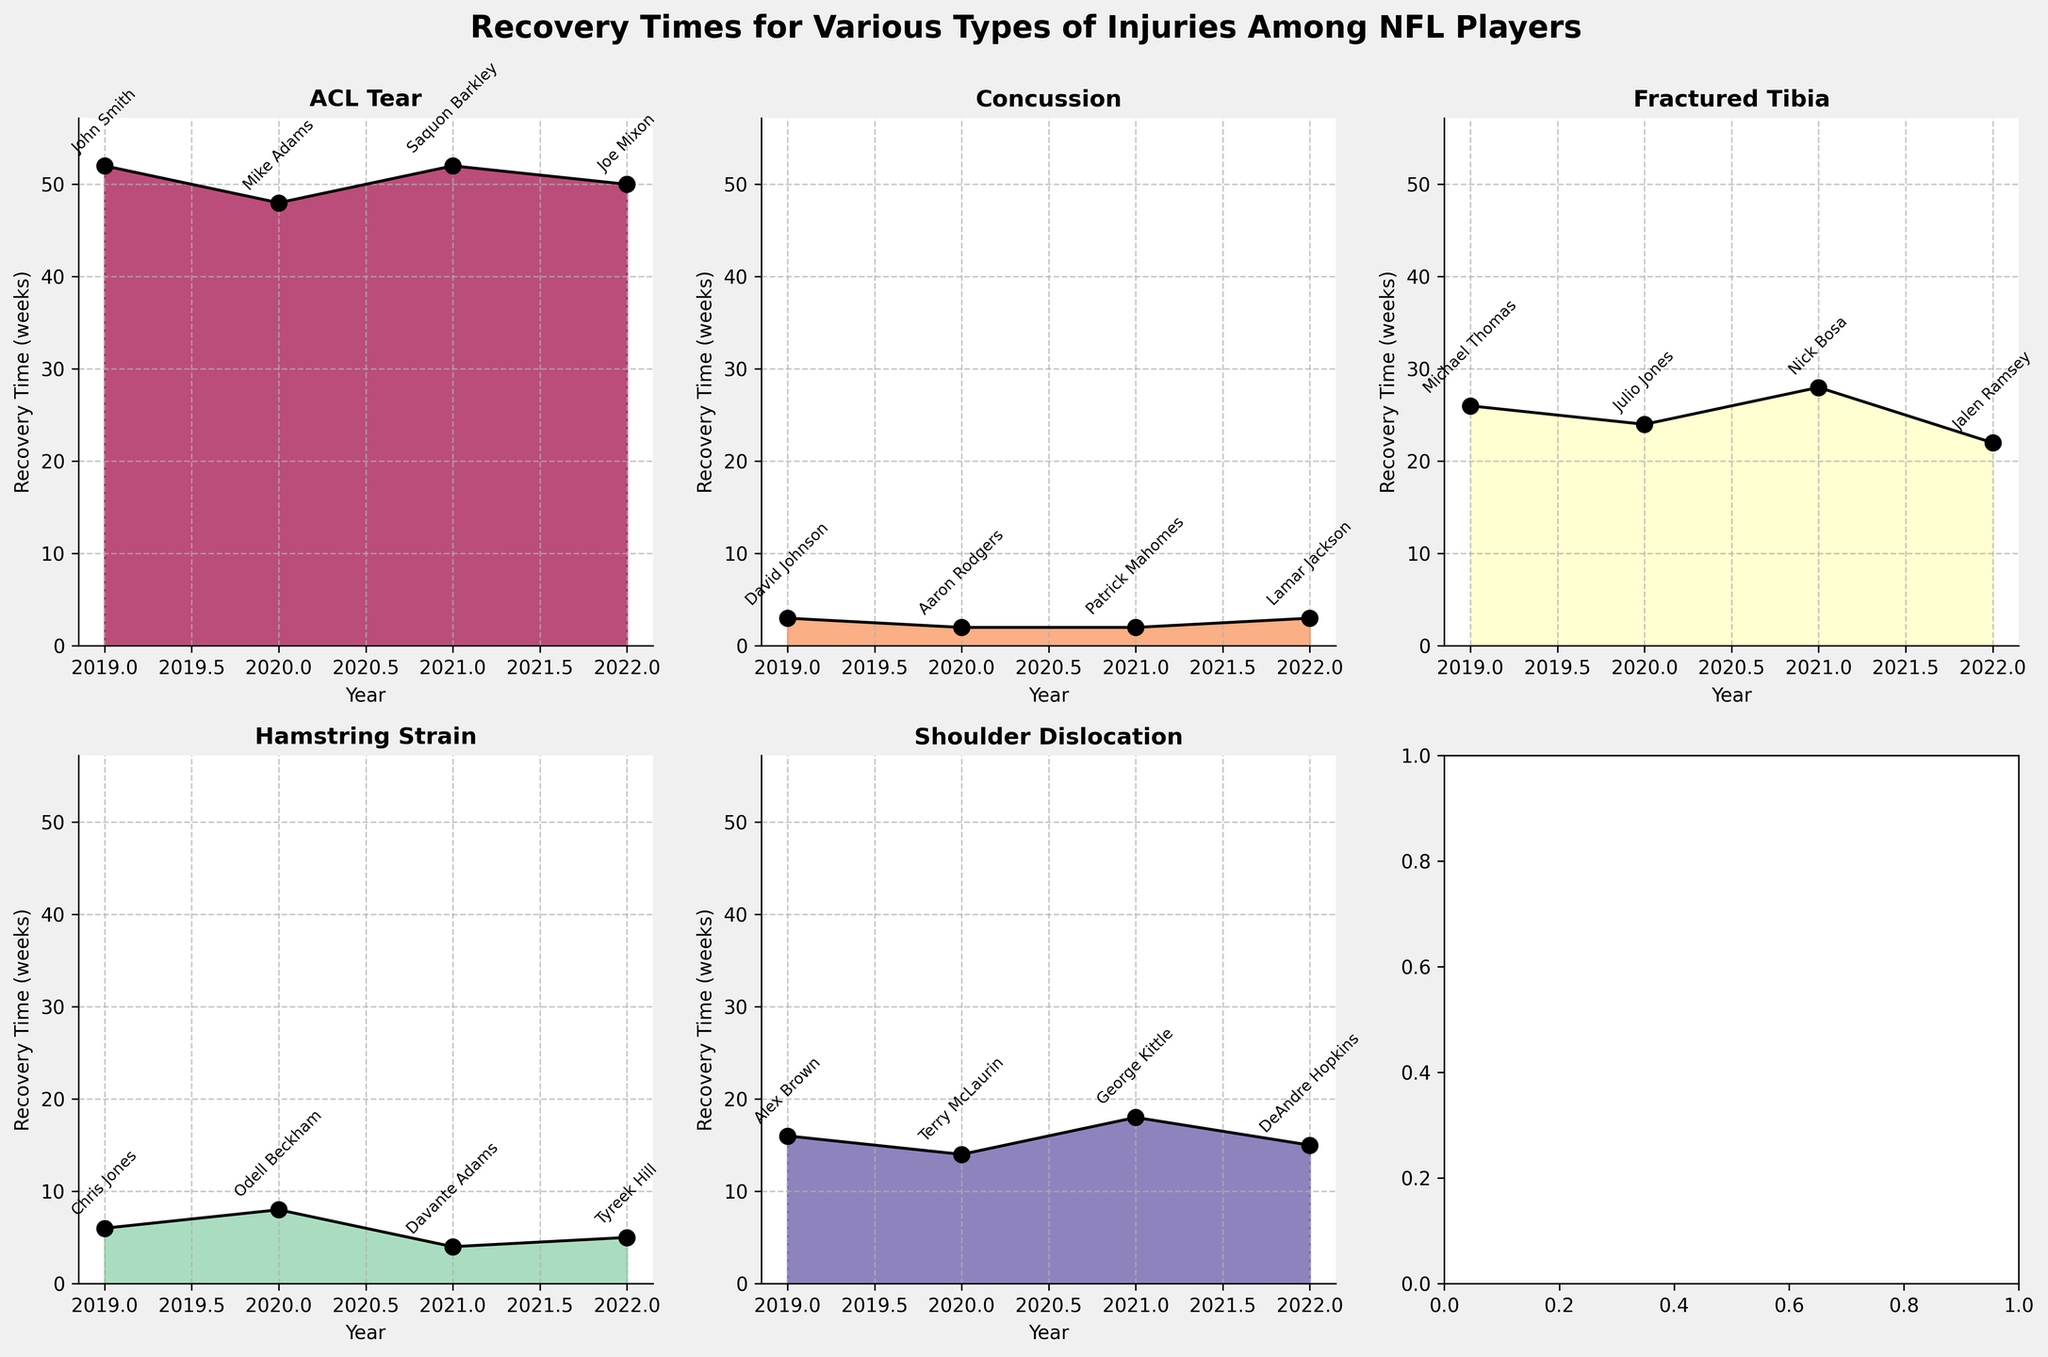What is the title of the figure? The title is displayed at the top of the figure in bold text. It states the overall subject of the data being represented.
Answer: Recovery Times for Various Types of Injuries Among NFL Players Which injury type shows the longest recovery time in 2021? The subplot titled "ACL Tear" shows the longest recovery time for 2021, with a value of 52 weeks attributed to Saquon Barkley.
Answer: ACL Tear How many players suffered from Concussions in 2020 according to the subplots? The subplot labeled "Concussion" has dots representing players and their recovery times. Counting the labels for 2020, we see only Aaron Rodgers.
Answer: 1 Which year has the shortest recovery time for Shoulder Dislocation? By examining the subplot titled "Shoulder Dislocation", we see that the shortest recovery time is 14 weeks in 2020, attributed to Terry McLaurin.
Answer: 2020 Compare the recovery times between ACL Tear and Hamstring Strain in 2019. Which one is longer? The 2019 data for "ACL Tear" shows a recovery time of 52 weeks for John Smith, while "Hamstring Strain" shows 6 weeks for Chris Jones. ACL Tear has a longer recovery time.
Answer: ACL Tear What is the average recovery time for Fractured Tibia injuries across all years? The recovery times for Fractured Tibia are: 26 (2019), 24 (2020), 28 (2021), and 22 (2022). Summing these gives 100, and dividing by 4 years provides the average. 100 / 4 = 25
Answer: 25 weeks Which injury type has the most consistent recovery times year to year? By examining the fluctuations in each subplot, we notice that "Concussion" has the smallest variance in recovery times, ranging from 2 to 3 weeks over all years.
Answer: Concussion What is the total recovery time for all ACL Tear injuries across all years? Summing the recovery times for ACL Tear: 52 (2019), 48 (2020), 52 (2021), and 50 (2022) gives us the total. 52 + 48 + 52 + 50 = 202 weeks.
Answer: 202 weeks 